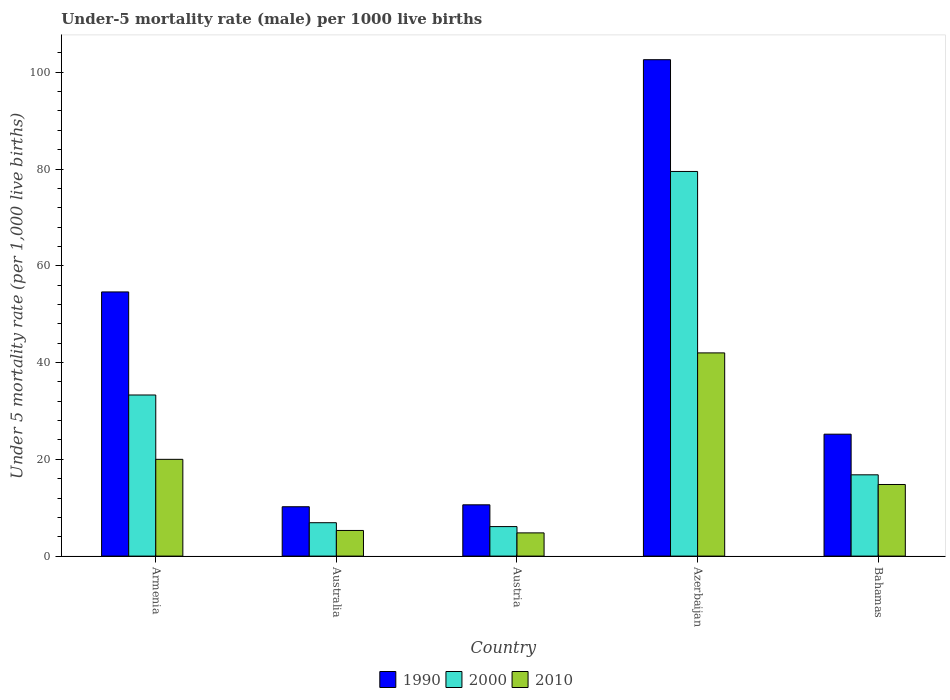How many groups of bars are there?
Keep it short and to the point. 5. Are the number of bars on each tick of the X-axis equal?
Provide a short and direct response. Yes. What is the label of the 4th group of bars from the left?
Offer a very short reply. Azerbaijan. What is the under-five mortality rate in 2010 in Austria?
Give a very brief answer. 4.8. Across all countries, what is the maximum under-five mortality rate in 2010?
Provide a succinct answer. 42. In which country was the under-five mortality rate in 2010 maximum?
Make the answer very short. Azerbaijan. In which country was the under-five mortality rate in 2010 minimum?
Your answer should be compact. Austria. What is the total under-five mortality rate in 2010 in the graph?
Ensure brevity in your answer.  86.9. What is the difference between the under-five mortality rate in 2000 in Austria and that in Azerbaijan?
Provide a succinct answer. -73.4. What is the difference between the under-five mortality rate in 2000 in Austria and the under-five mortality rate in 2010 in Azerbaijan?
Your answer should be very brief. -35.9. What is the average under-five mortality rate in 1990 per country?
Your answer should be compact. 40.64. What is the ratio of the under-five mortality rate in 2010 in Armenia to that in Bahamas?
Your answer should be compact. 1.35. Is the under-five mortality rate in 2010 in Austria less than that in Bahamas?
Offer a terse response. Yes. What is the difference between the highest and the lowest under-five mortality rate in 1990?
Your answer should be compact. 92.4. In how many countries, is the under-five mortality rate in 1990 greater than the average under-five mortality rate in 1990 taken over all countries?
Your response must be concise. 2. Is the sum of the under-five mortality rate in 2010 in Australia and Bahamas greater than the maximum under-five mortality rate in 2000 across all countries?
Your response must be concise. No. How many bars are there?
Keep it short and to the point. 15. Are the values on the major ticks of Y-axis written in scientific E-notation?
Provide a succinct answer. No. Does the graph contain any zero values?
Make the answer very short. No. Where does the legend appear in the graph?
Your answer should be compact. Bottom center. How many legend labels are there?
Offer a terse response. 3. How are the legend labels stacked?
Your answer should be compact. Horizontal. What is the title of the graph?
Your answer should be very brief. Under-5 mortality rate (male) per 1000 live births. Does "2013" appear as one of the legend labels in the graph?
Keep it short and to the point. No. What is the label or title of the X-axis?
Ensure brevity in your answer.  Country. What is the label or title of the Y-axis?
Your response must be concise. Under 5 mortality rate (per 1,0 live births). What is the Under 5 mortality rate (per 1,000 live births) of 1990 in Armenia?
Provide a short and direct response. 54.6. What is the Under 5 mortality rate (per 1,000 live births) in 2000 in Armenia?
Your response must be concise. 33.3. What is the Under 5 mortality rate (per 1,000 live births) in 2010 in Australia?
Offer a terse response. 5.3. What is the Under 5 mortality rate (per 1,000 live births) of 2000 in Austria?
Your answer should be very brief. 6.1. What is the Under 5 mortality rate (per 1,000 live births) of 2010 in Austria?
Offer a very short reply. 4.8. What is the Under 5 mortality rate (per 1,000 live births) in 1990 in Azerbaijan?
Provide a short and direct response. 102.6. What is the Under 5 mortality rate (per 1,000 live births) in 2000 in Azerbaijan?
Ensure brevity in your answer.  79.5. What is the Under 5 mortality rate (per 1,000 live births) in 1990 in Bahamas?
Ensure brevity in your answer.  25.2. What is the Under 5 mortality rate (per 1,000 live births) in 2000 in Bahamas?
Provide a short and direct response. 16.8. What is the Under 5 mortality rate (per 1,000 live births) of 2010 in Bahamas?
Keep it short and to the point. 14.8. Across all countries, what is the maximum Under 5 mortality rate (per 1,000 live births) of 1990?
Offer a very short reply. 102.6. Across all countries, what is the maximum Under 5 mortality rate (per 1,000 live births) of 2000?
Make the answer very short. 79.5. Across all countries, what is the minimum Under 5 mortality rate (per 1,000 live births) of 1990?
Provide a short and direct response. 10.2. Across all countries, what is the minimum Under 5 mortality rate (per 1,000 live births) in 2000?
Ensure brevity in your answer.  6.1. What is the total Under 5 mortality rate (per 1,000 live births) in 1990 in the graph?
Your answer should be very brief. 203.2. What is the total Under 5 mortality rate (per 1,000 live births) of 2000 in the graph?
Your answer should be very brief. 142.6. What is the total Under 5 mortality rate (per 1,000 live births) of 2010 in the graph?
Give a very brief answer. 86.9. What is the difference between the Under 5 mortality rate (per 1,000 live births) in 1990 in Armenia and that in Australia?
Give a very brief answer. 44.4. What is the difference between the Under 5 mortality rate (per 1,000 live births) of 2000 in Armenia and that in Australia?
Offer a very short reply. 26.4. What is the difference between the Under 5 mortality rate (per 1,000 live births) in 2010 in Armenia and that in Australia?
Offer a very short reply. 14.7. What is the difference between the Under 5 mortality rate (per 1,000 live births) in 1990 in Armenia and that in Austria?
Ensure brevity in your answer.  44. What is the difference between the Under 5 mortality rate (per 1,000 live births) in 2000 in Armenia and that in Austria?
Provide a succinct answer. 27.2. What is the difference between the Under 5 mortality rate (per 1,000 live births) of 1990 in Armenia and that in Azerbaijan?
Offer a very short reply. -48. What is the difference between the Under 5 mortality rate (per 1,000 live births) in 2000 in Armenia and that in Azerbaijan?
Your answer should be compact. -46.2. What is the difference between the Under 5 mortality rate (per 1,000 live births) of 2010 in Armenia and that in Azerbaijan?
Offer a very short reply. -22. What is the difference between the Under 5 mortality rate (per 1,000 live births) of 1990 in Armenia and that in Bahamas?
Provide a succinct answer. 29.4. What is the difference between the Under 5 mortality rate (per 1,000 live births) of 1990 in Australia and that in Austria?
Provide a succinct answer. -0.4. What is the difference between the Under 5 mortality rate (per 1,000 live births) of 1990 in Australia and that in Azerbaijan?
Offer a terse response. -92.4. What is the difference between the Under 5 mortality rate (per 1,000 live births) of 2000 in Australia and that in Azerbaijan?
Your answer should be very brief. -72.6. What is the difference between the Under 5 mortality rate (per 1,000 live births) of 2010 in Australia and that in Azerbaijan?
Your answer should be compact. -36.7. What is the difference between the Under 5 mortality rate (per 1,000 live births) in 1990 in Australia and that in Bahamas?
Make the answer very short. -15. What is the difference between the Under 5 mortality rate (per 1,000 live births) in 2000 in Australia and that in Bahamas?
Offer a terse response. -9.9. What is the difference between the Under 5 mortality rate (per 1,000 live births) of 1990 in Austria and that in Azerbaijan?
Provide a short and direct response. -92. What is the difference between the Under 5 mortality rate (per 1,000 live births) of 2000 in Austria and that in Azerbaijan?
Provide a succinct answer. -73.4. What is the difference between the Under 5 mortality rate (per 1,000 live births) in 2010 in Austria and that in Azerbaijan?
Provide a short and direct response. -37.2. What is the difference between the Under 5 mortality rate (per 1,000 live births) of 1990 in Austria and that in Bahamas?
Your answer should be very brief. -14.6. What is the difference between the Under 5 mortality rate (per 1,000 live births) in 2000 in Austria and that in Bahamas?
Make the answer very short. -10.7. What is the difference between the Under 5 mortality rate (per 1,000 live births) in 1990 in Azerbaijan and that in Bahamas?
Provide a succinct answer. 77.4. What is the difference between the Under 5 mortality rate (per 1,000 live births) of 2000 in Azerbaijan and that in Bahamas?
Provide a succinct answer. 62.7. What is the difference between the Under 5 mortality rate (per 1,000 live births) of 2010 in Azerbaijan and that in Bahamas?
Provide a succinct answer. 27.2. What is the difference between the Under 5 mortality rate (per 1,000 live births) of 1990 in Armenia and the Under 5 mortality rate (per 1,000 live births) of 2000 in Australia?
Make the answer very short. 47.7. What is the difference between the Under 5 mortality rate (per 1,000 live births) in 1990 in Armenia and the Under 5 mortality rate (per 1,000 live births) in 2010 in Australia?
Offer a very short reply. 49.3. What is the difference between the Under 5 mortality rate (per 1,000 live births) of 1990 in Armenia and the Under 5 mortality rate (per 1,000 live births) of 2000 in Austria?
Provide a short and direct response. 48.5. What is the difference between the Under 5 mortality rate (per 1,000 live births) in 1990 in Armenia and the Under 5 mortality rate (per 1,000 live births) in 2010 in Austria?
Offer a very short reply. 49.8. What is the difference between the Under 5 mortality rate (per 1,000 live births) in 1990 in Armenia and the Under 5 mortality rate (per 1,000 live births) in 2000 in Azerbaijan?
Your response must be concise. -24.9. What is the difference between the Under 5 mortality rate (per 1,000 live births) of 1990 in Armenia and the Under 5 mortality rate (per 1,000 live births) of 2010 in Azerbaijan?
Make the answer very short. 12.6. What is the difference between the Under 5 mortality rate (per 1,000 live births) of 2000 in Armenia and the Under 5 mortality rate (per 1,000 live births) of 2010 in Azerbaijan?
Give a very brief answer. -8.7. What is the difference between the Under 5 mortality rate (per 1,000 live births) of 1990 in Armenia and the Under 5 mortality rate (per 1,000 live births) of 2000 in Bahamas?
Your response must be concise. 37.8. What is the difference between the Under 5 mortality rate (per 1,000 live births) in 1990 in Armenia and the Under 5 mortality rate (per 1,000 live births) in 2010 in Bahamas?
Provide a succinct answer. 39.8. What is the difference between the Under 5 mortality rate (per 1,000 live births) of 1990 in Australia and the Under 5 mortality rate (per 1,000 live births) of 2000 in Azerbaijan?
Provide a short and direct response. -69.3. What is the difference between the Under 5 mortality rate (per 1,000 live births) in 1990 in Australia and the Under 5 mortality rate (per 1,000 live births) in 2010 in Azerbaijan?
Keep it short and to the point. -31.8. What is the difference between the Under 5 mortality rate (per 1,000 live births) in 2000 in Australia and the Under 5 mortality rate (per 1,000 live births) in 2010 in Azerbaijan?
Keep it short and to the point. -35.1. What is the difference between the Under 5 mortality rate (per 1,000 live births) of 1990 in Australia and the Under 5 mortality rate (per 1,000 live births) of 2010 in Bahamas?
Your answer should be very brief. -4.6. What is the difference between the Under 5 mortality rate (per 1,000 live births) in 2000 in Australia and the Under 5 mortality rate (per 1,000 live births) in 2010 in Bahamas?
Provide a short and direct response. -7.9. What is the difference between the Under 5 mortality rate (per 1,000 live births) in 1990 in Austria and the Under 5 mortality rate (per 1,000 live births) in 2000 in Azerbaijan?
Your answer should be very brief. -68.9. What is the difference between the Under 5 mortality rate (per 1,000 live births) in 1990 in Austria and the Under 5 mortality rate (per 1,000 live births) in 2010 in Azerbaijan?
Keep it short and to the point. -31.4. What is the difference between the Under 5 mortality rate (per 1,000 live births) in 2000 in Austria and the Under 5 mortality rate (per 1,000 live births) in 2010 in Azerbaijan?
Provide a short and direct response. -35.9. What is the difference between the Under 5 mortality rate (per 1,000 live births) in 1990 in Austria and the Under 5 mortality rate (per 1,000 live births) in 2010 in Bahamas?
Provide a short and direct response. -4.2. What is the difference between the Under 5 mortality rate (per 1,000 live births) in 1990 in Azerbaijan and the Under 5 mortality rate (per 1,000 live births) in 2000 in Bahamas?
Provide a succinct answer. 85.8. What is the difference between the Under 5 mortality rate (per 1,000 live births) in 1990 in Azerbaijan and the Under 5 mortality rate (per 1,000 live births) in 2010 in Bahamas?
Provide a short and direct response. 87.8. What is the difference between the Under 5 mortality rate (per 1,000 live births) of 2000 in Azerbaijan and the Under 5 mortality rate (per 1,000 live births) of 2010 in Bahamas?
Offer a terse response. 64.7. What is the average Under 5 mortality rate (per 1,000 live births) in 1990 per country?
Provide a succinct answer. 40.64. What is the average Under 5 mortality rate (per 1,000 live births) in 2000 per country?
Ensure brevity in your answer.  28.52. What is the average Under 5 mortality rate (per 1,000 live births) in 2010 per country?
Make the answer very short. 17.38. What is the difference between the Under 5 mortality rate (per 1,000 live births) of 1990 and Under 5 mortality rate (per 1,000 live births) of 2000 in Armenia?
Make the answer very short. 21.3. What is the difference between the Under 5 mortality rate (per 1,000 live births) in 1990 and Under 5 mortality rate (per 1,000 live births) in 2010 in Armenia?
Your response must be concise. 34.6. What is the difference between the Under 5 mortality rate (per 1,000 live births) of 2000 and Under 5 mortality rate (per 1,000 live births) of 2010 in Armenia?
Your response must be concise. 13.3. What is the difference between the Under 5 mortality rate (per 1,000 live births) of 1990 and Under 5 mortality rate (per 1,000 live births) of 2000 in Australia?
Make the answer very short. 3.3. What is the difference between the Under 5 mortality rate (per 1,000 live births) of 1990 and Under 5 mortality rate (per 1,000 live births) of 2010 in Australia?
Offer a very short reply. 4.9. What is the difference between the Under 5 mortality rate (per 1,000 live births) in 2000 and Under 5 mortality rate (per 1,000 live births) in 2010 in Australia?
Give a very brief answer. 1.6. What is the difference between the Under 5 mortality rate (per 1,000 live births) in 1990 and Under 5 mortality rate (per 1,000 live births) in 2010 in Austria?
Your response must be concise. 5.8. What is the difference between the Under 5 mortality rate (per 1,000 live births) in 2000 and Under 5 mortality rate (per 1,000 live births) in 2010 in Austria?
Your answer should be very brief. 1.3. What is the difference between the Under 5 mortality rate (per 1,000 live births) of 1990 and Under 5 mortality rate (per 1,000 live births) of 2000 in Azerbaijan?
Your response must be concise. 23.1. What is the difference between the Under 5 mortality rate (per 1,000 live births) in 1990 and Under 5 mortality rate (per 1,000 live births) in 2010 in Azerbaijan?
Keep it short and to the point. 60.6. What is the difference between the Under 5 mortality rate (per 1,000 live births) in 2000 and Under 5 mortality rate (per 1,000 live births) in 2010 in Azerbaijan?
Offer a very short reply. 37.5. What is the difference between the Under 5 mortality rate (per 1,000 live births) in 1990 and Under 5 mortality rate (per 1,000 live births) in 2010 in Bahamas?
Offer a very short reply. 10.4. What is the ratio of the Under 5 mortality rate (per 1,000 live births) in 1990 in Armenia to that in Australia?
Your answer should be compact. 5.35. What is the ratio of the Under 5 mortality rate (per 1,000 live births) in 2000 in Armenia to that in Australia?
Keep it short and to the point. 4.83. What is the ratio of the Under 5 mortality rate (per 1,000 live births) in 2010 in Armenia to that in Australia?
Offer a terse response. 3.77. What is the ratio of the Under 5 mortality rate (per 1,000 live births) in 1990 in Armenia to that in Austria?
Offer a terse response. 5.15. What is the ratio of the Under 5 mortality rate (per 1,000 live births) of 2000 in Armenia to that in Austria?
Your answer should be very brief. 5.46. What is the ratio of the Under 5 mortality rate (per 1,000 live births) in 2010 in Armenia to that in Austria?
Your answer should be compact. 4.17. What is the ratio of the Under 5 mortality rate (per 1,000 live births) of 1990 in Armenia to that in Azerbaijan?
Provide a succinct answer. 0.53. What is the ratio of the Under 5 mortality rate (per 1,000 live births) of 2000 in Armenia to that in Azerbaijan?
Your answer should be compact. 0.42. What is the ratio of the Under 5 mortality rate (per 1,000 live births) in 2010 in Armenia to that in Azerbaijan?
Your answer should be compact. 0.48. What is the ratio of the Under 5 mortality rate (per 1,000 live births) in 1990 in Armenia to that in Bahamas?
Offer a very short reply. 2.17. What is the ratio of the Under 5 mortality rate (per 1,000 live births) of 2000 in Armenia to that in Bahamas?
Keep it short and to the point. 1.98. What is the ratio of the Under 5 mortality rate (per 1,000 live births) of 2010 in Armenia to that in Bahamas?
Make the answer very short. 1.35. What is the ratio of the Under 5 mortality rate (per 1,000 live births) in 1990 in Australia to that in Austria?
Offer a terse response. 0.96. What is the ratio of the Under 5 mortality rate (per 1,000 live births) in 2000 in Australia to that in Austria?
Your answer should be very brief. 1.13. What is the ratio of the Under 5 mortality rate (per 1,000 live births) of 2010 in Australia to that in Austria?
Offer a terse response. 1.1. What is the ratio of the Under 5 mortality rate (per 1,000 live births) in 1990 in Australia to that in Azerbaijan?
Ensure brevity in your answer.  0.1. What is the ratio of the Under 5 mortality rate (per 1,000 live births) of 2000 in Australia to that in Azerbaijan?
Ensure brevity in your answer.  0.09. What is the ratio of the Under 5 mortality rate (per 1,000 live births) in 2010 in Australia to that in Azerbaijan?
Your answer should be compact. 0.13. What is the ratio of the Under 5 mortality rate (per 1,000 live births) in 1990 in Australia to that in Bahamas?
Make the answer very short. 0.4. What is the ratio of the Under 5 mortality rate (per 1,000 live births) in 2000 in Australia to that in Bahamas?
Make the answer very short. 0.41. What is the ratio of the Under 5 mortality rate (per 1,000 live births) in 2010 in Australia to that in Bahamas?
Provide a succinct answer. 0.36. What is the ratio of the Under 5 mortality rate (per 1,000 live births) of 1990 in Austria to that in Azerbaijan?
Offer a very short reply. 0.1. What is the ratio of the Under 5 mortality rate (per 1,000 live births) of 2000 in Austria to that in Azerbaijan?
Provide a succinct answer. 0.08. What is the ratio of the Under 5 mortality rate (per 1,000 live births) in 2010 in Austria to that in Azerbaijan?
Provide a short and direct response. 0.11. What is the ratio of the Under 5 mortality rate (per 1,000 live births) in 1990 in Austria to that in Bahamas?
Your answer should be very brief. 0.42. What is the ratio of the Under 5 mortality rate (per 1,000 live births) of 2000 in Austria to that in Bahamas?
Your answer should be compact. 0.36. What is the ratio of the Under 5 mortality rate (per 1,000 live births) in 2010 in Austria to that in Bahamas?
Provide a short and direct response. 0.32. What is the ratio of the Under 5 mortality rate (per 1,000 live births) in 1990 in Azerbaijan to that in Bahamas?
Offer a very short reply. 4.07. What is the ratio of the Under 5 mortality rate (per 1,000 live births) of 2000 in Azerbaijan to that in Bahamas?
Provide a short and direct response. 4.73. What is the ratio of the Under 5 mortality rate (per 1,000 live births) of 2010 in Azerbaijan to that in Bahamas?
Your answer should be very brief. 2.84. What is the difference between the highest and the second highest Under 5 mortality rate (per 1,000 live births) of 1990?
Provide a succinct answer. 48. What is the difference between the highest and the second highest Under 5 mortality rate (per 1,000 live births) in 2000?
Give a very brief answer. 46.2. What is the difference between the highest and the lowest Under 5 mortality rate (per 1,000 live births) in 1990?
Provide a short and direct response. 92.4. What is the difference between the highest and the lowest Under 5 mortality rate (per 1,000 live births) of 2000?
Your answer should be compact. 73.4. What is the difference between the highest and the lowest Under 5 mortality rate (per 1,000 live births) in 2010?
Give a very brief answer. 37.2. 